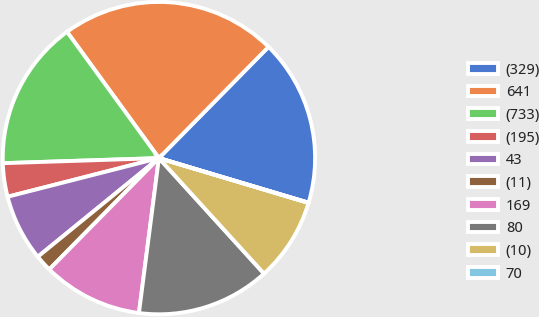<chart> <loc_0><loc_0><loc_500><loc_500><pie_chart><fcel>(329)<fcel>641<fcel>(733)<fcel>(195)<fcel>43<fcel>(11)<fcel>169<fcel>80<fcel>(10)<fcel>70<nl><fcel>17.23%<fcel>22.39%<fcel>15.51%<fcel>3.46%<fcel>6.9%<fcel>1.74%<fcel>10.34%<fcel>13.79%<fcel>8.62%<fcel>0.02%<nl></chart> 